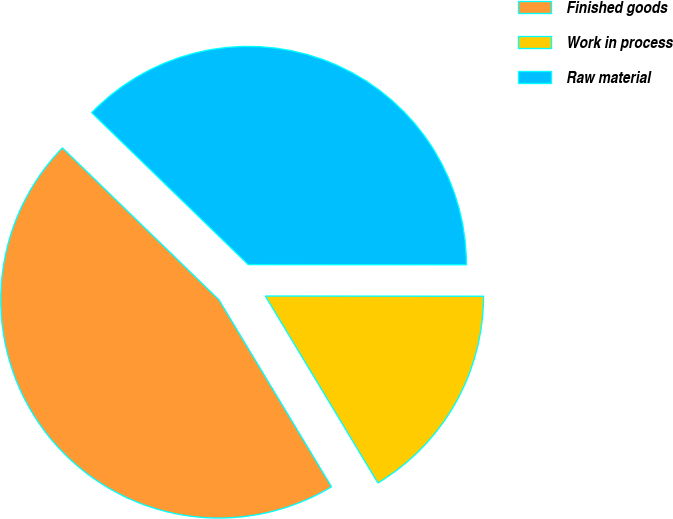<chart> <loc_0><loc_0><loc_500><loc_500><pie_chart><fcel>Finished goods<fcel>Work in process<fcel>Raw material<nl><fcel>45.89%<fcel>16.36%<fcel>37.75%<nl></chart> 